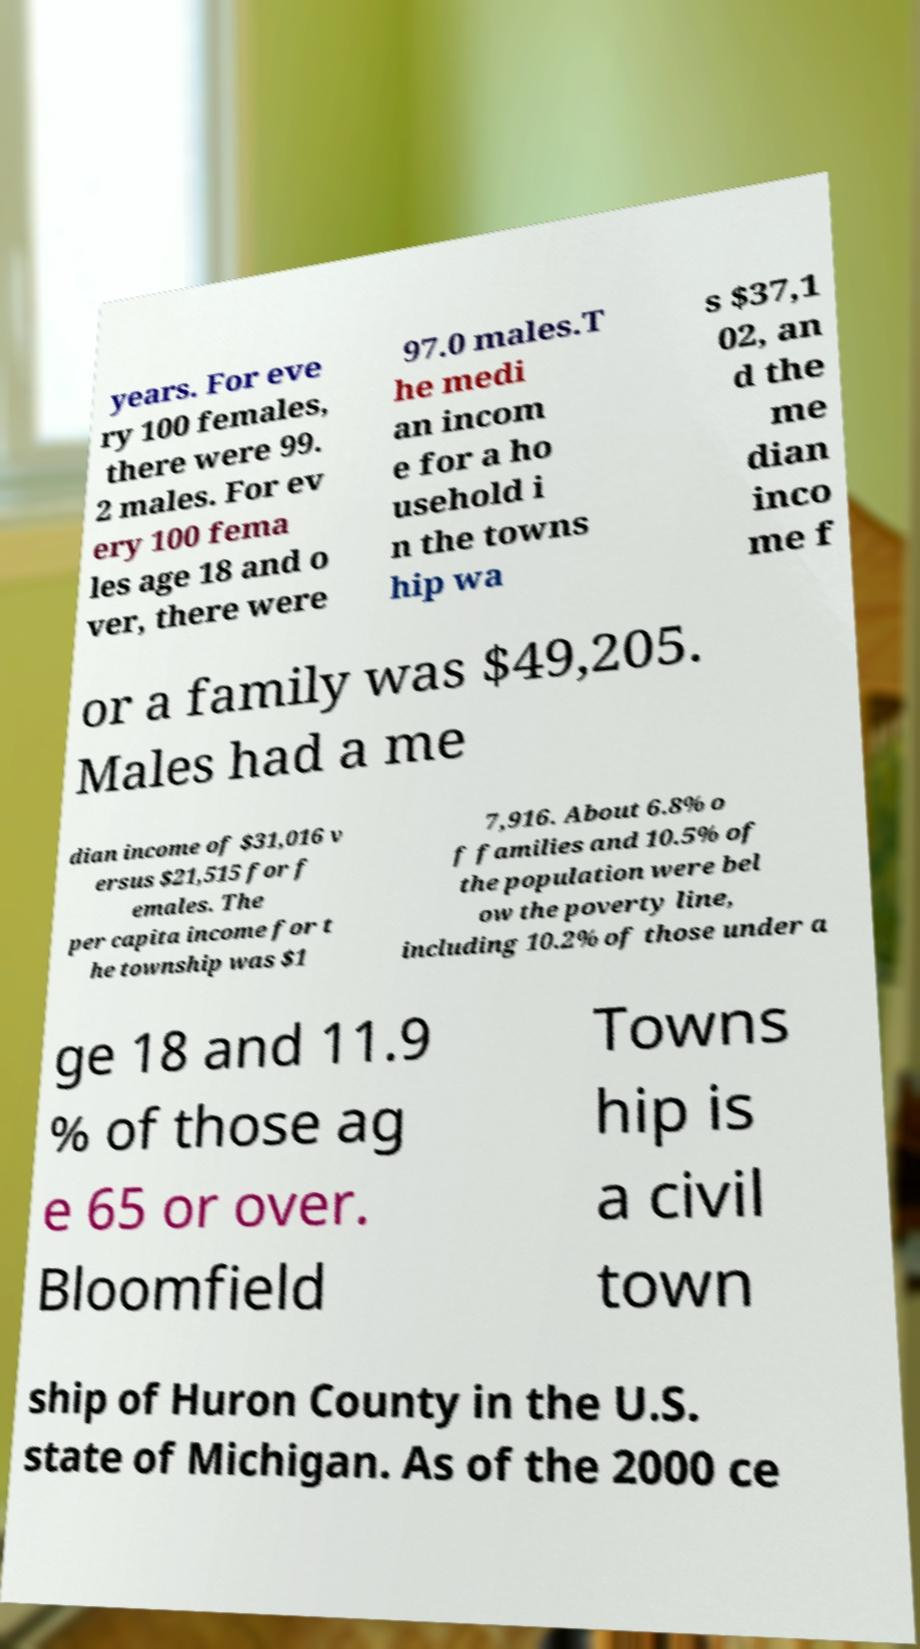For documentation purposes, I need the text within this image transcribed. Could you provide that? years. For eve ry 100 females, there were 99. 2 males. For ev ery 100 fema les age 18 and o ver, there were 97.0 males.T he medi an incom e for a ho usehold i n the towns hip wa s $37,1 02, an d the me dian inco me f or a family was $49,205. Males had a me dian income of $31,016 v ersus $21,515 for f emales. The per capita income for t he township was $1 7,916. About 6.8% o f families and 10.5% of the population were bel ow the poverty line, including 10.2% of those under a ge 18 and 11.9 % of those ag e 65 or over. Bloomfield Towns hip is a civil town ship of Huron County in the U.S. state of Michigan. As of the 2000 ce 